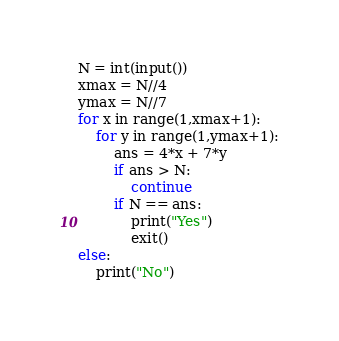<code> <loc_0><loc_0><loc_500><loc_500><_Python_>N = int(input())
xmax = N//4
ymax = N//7
for x in range(1,xmax+1):
    for y in range(1,ymax+1):
        ans = 4*x + 7*y
        if ans > N:
            continue
        if N == ans:
            print("Yes")
            exit()
else:
    print("No")</code> 